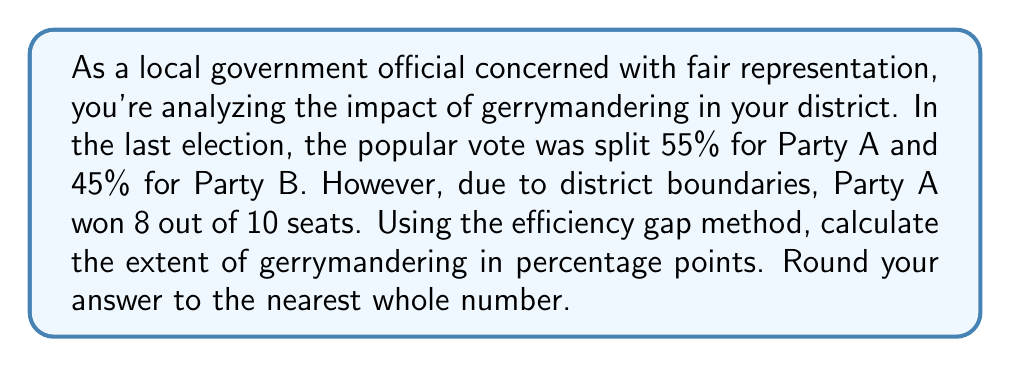Can you answer this question? To solve this problem, we'll use the efficiency gap method, which measures the difference in wasted votes between parties.

Step 1: Calculate the expected number of seats for Party A based on the popular vote.
Expected seats for Party A = $0.55 \times 10 = 5.5$ seats

Step 2: Calculate the difference between actual and expected seats for Party A.
Seat difference = Actual seats - Expected seats
$$ \text{Seat difference} = 8 - 5.5 = 2.5 \text{ seats} $$

Step 3: Convert the seat difference to a percentage of total seats.
$$ \text{Efficiency gap} = \frac{\text{Seat difference}}{\text{Total seats}} \times 100\% $$
$$ \text{Efficiency gap} = \frac{2.5}{10} \times 100\% = 25\% $$

Step 4: Round to the nearest whole number.
Rounded efficiency gap = 25%

The efficiency gap of 25 percentage points indicates significant gerrymandering in favor of Party A.
Answer: 25% 